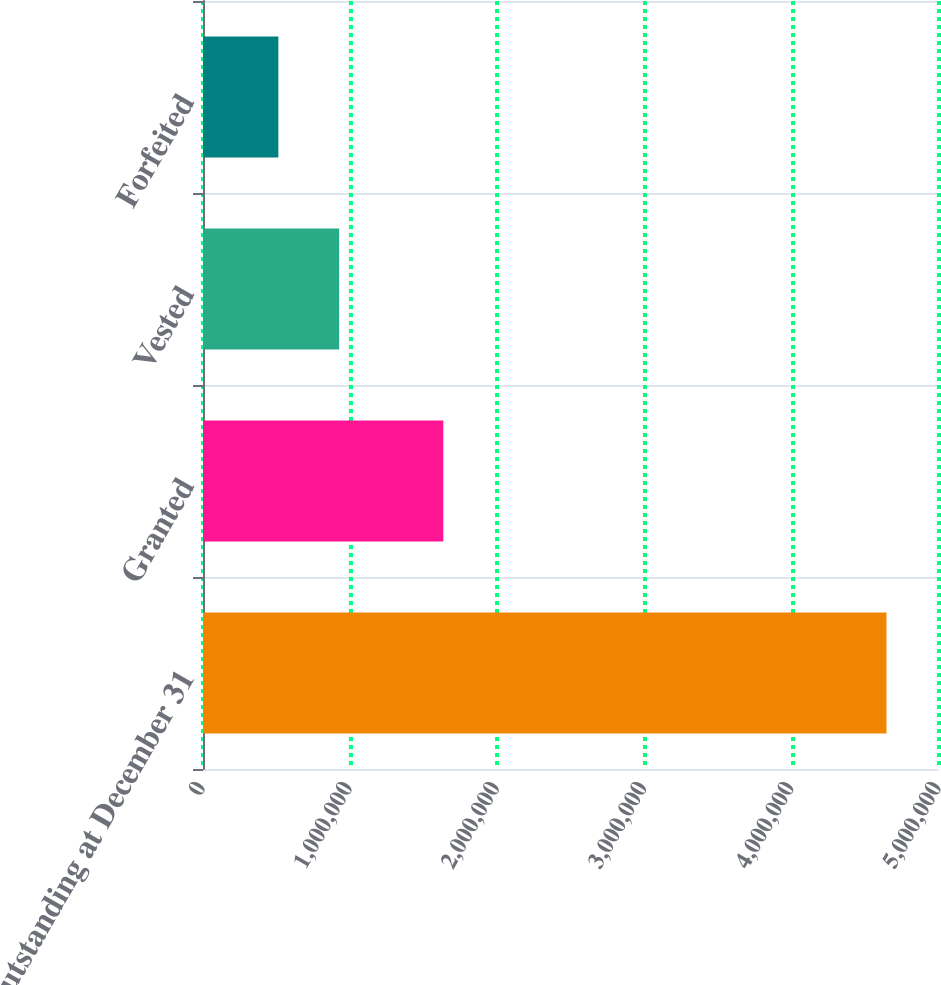Convert chart to OTSL. <chart><loc_0><loc_0><loc_500><loc_500><bar_chart><fcel>Outstanding at December 31<fcel>Granted<fcel>Vested<fcel>Forfeited<nl><fcel>4.64311e+06<fcel>1.63264e+06<fcel>925083<fcel>511969<nl></chart> 